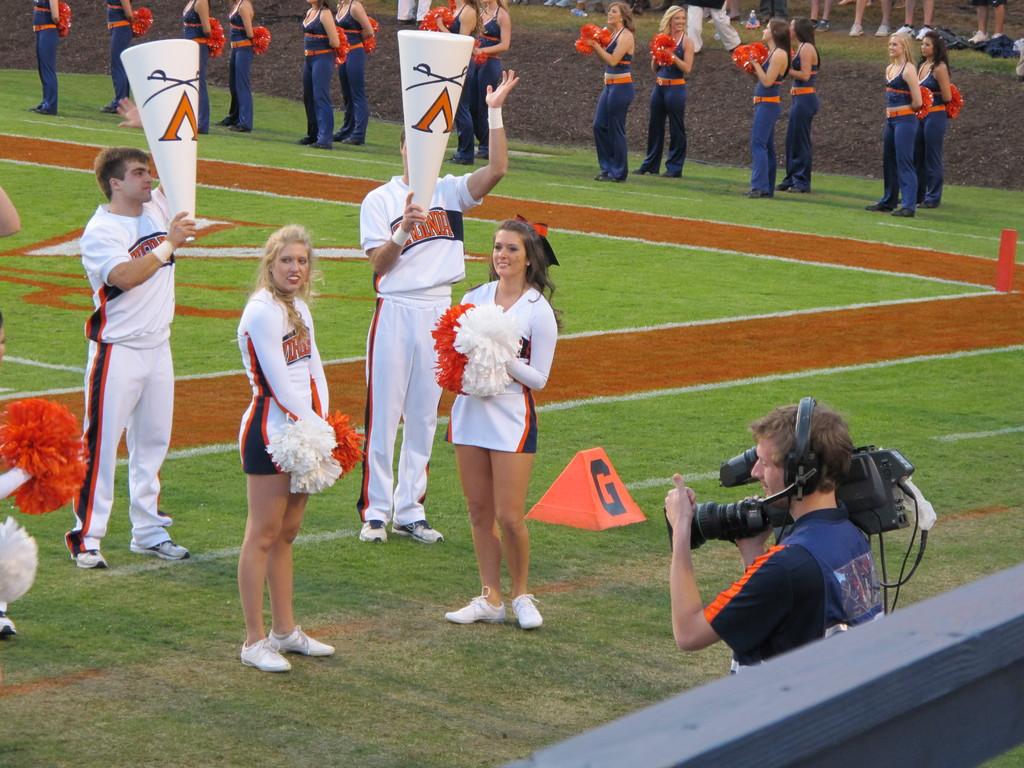What letter is on the megaphone?
Your answer should be very brief. V. What letter is on the orange sign on the ground?
Your answer should be very brief. G. 